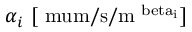<formula> <loc_0><loc_0><loc_500><loc_500>\alpha _ { i } \ [ \ m u m / s / m ^ { \ b e t a _ { i } } ]</formula> 